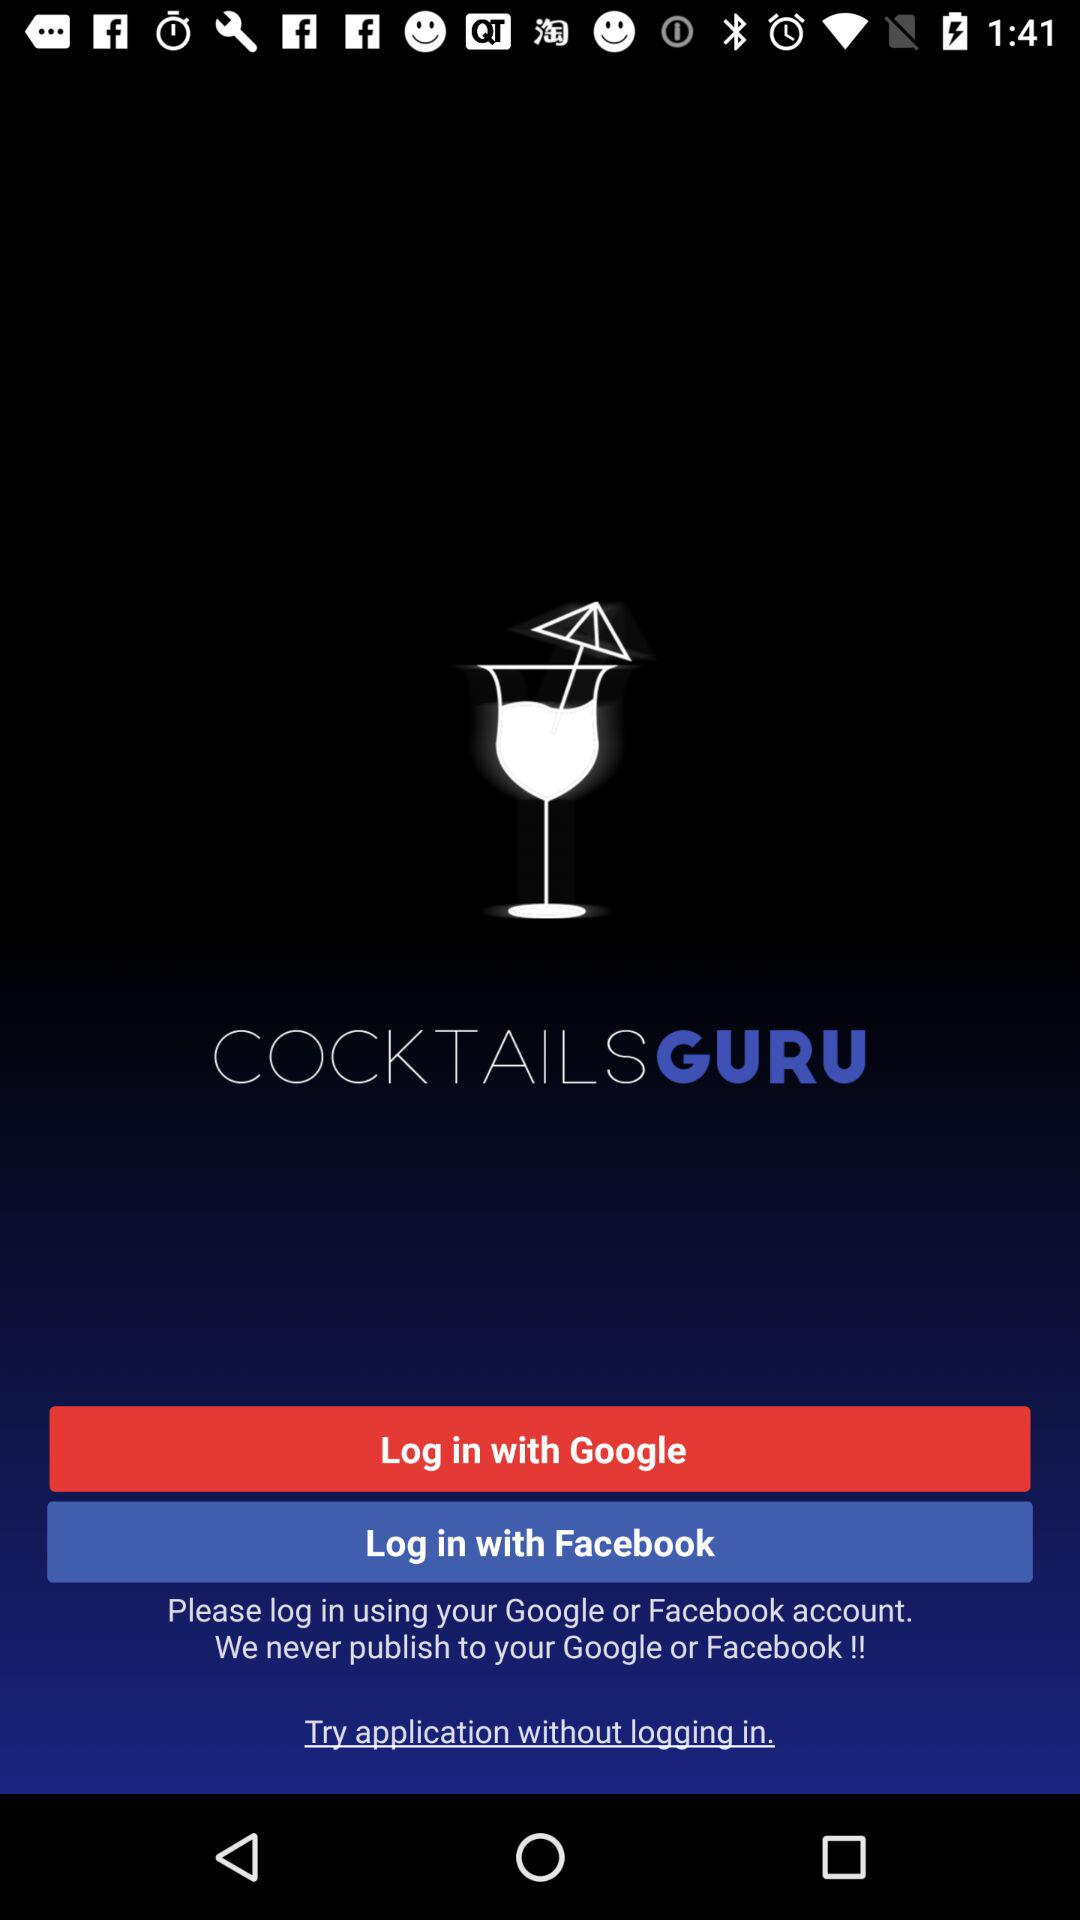What is the application name? The application name is "COCKTAILS GURU". 